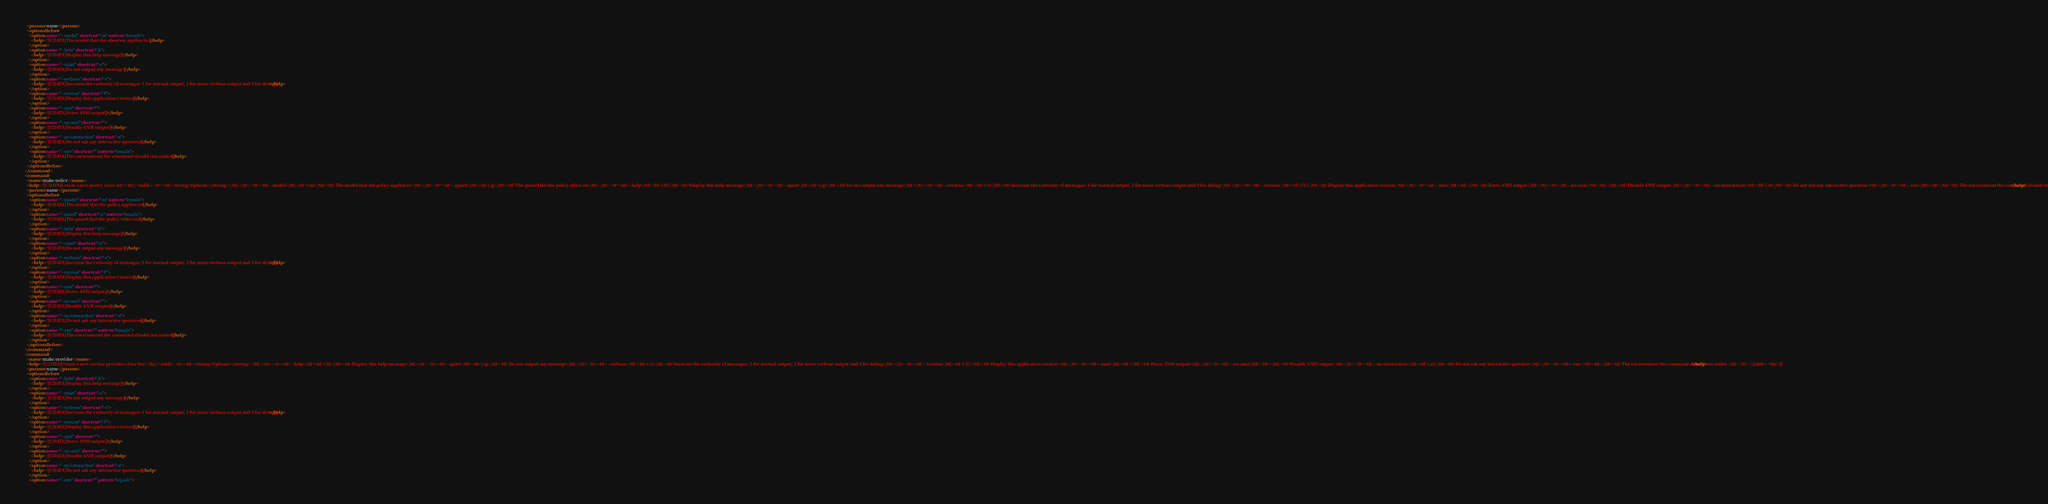Convert code to text. <code><loc_0><loc_0><loc_500><loc_500><_XML_>    <params>name</params>
    <optionsBefore>
      <option name="--model" shortcut="-m" pattern="equals">
        <help><![CDATA[The model that the observer applies to.]]></help>
      </option>
      <option name="--help" shortcut="-h">
        <help><![CDATA[Display this help message]]></help>
      </option>
      <option name="--quiet" shortcut="-q">
        <help><![CDATA[Do not output any message]]></help>
      </option>
      <option name="--verbose" shortcut="-v">
        <help><![CDATA[Increase the verbosity of messages: 1 for normal output, 2 for more verbose output and 3 for debug]]></help>
      </option>
      <option name="--version" shortcut="-V">
        <help><![CDATA[Display this application version]]></help>
      </option>
      <option name="--ansi" shortcut="">
        <help><![CDATA[Force ANSI output]]></help>
      </option>
      <option name="--no-ansi" shortcut="">
        <help><![CDATA[Disable ANSI output]]></help>
      </option>
      <option name="--no-interaction" shortcut="-n">
        <help><![CDATA[Do not ask any interactive question]]></help>
      </option>
      <option name="--env" shortcut="" pattern="equals">
        <help><![CDATA[The environment the command should run under]]></help>
      </option>
    </optionsBefore>
  </command>
  <command>
    <name>make:policy</name>
    <help><![CDATA[Create a new policy class<br/><br/><table> <tr><td><strong>Options:</strong></td></tr> <tr><td>--model</td><td>(-m)</td><td>The model that the policy applies to</td></tr> <tr><td>--guard</td><td>(-g)</td><td>The guard that the policy relies on</td></tr> <tr><td>--help</td><td>(-h)</td><td>Display this help message</td></tr> <tr><td>--quiet</td><td>(-q)</td><td>Do not output any message</td></tr> <tr><td>--verbose</td><td>(-v)</td><td>Increase the verbosity of messages: 1 for normal output, 2 for more verbose output and 3 for debug</td></tr> <tr><td>--version</td><td>(-V)</td><td>Display this application version</td></tr> <tr><td>--ansi</td><td></td><td>Force ANSI output</td></tr> <tr><td>--no-ansi</td><td></td><td>Disable ANSI output</td></tr> <tr><td>--no-interaction</td><td>(-n)</td><td>Do not ask any interactive question</td></tr> <tr><td>--env</td><td></td><td>The environment the command should run under</td></tr> </table> <br/>]]></help>
    <params>name</params>
    <optionsBefore>
      <option name="--model" shortcut="-m" pattern="equals">
        <help><![CDATA[The model that the policy applies to]]></help>
      </option>
      <option name="--guard" shortcut="-g" pattern="equals">
        <help><![CDATA[The guard that the policy relies on]]></help>
      </option>
      <option name="--help" shortcut="-h">
        <help><![CDATA[Display this help message]]></help>
      </option>
      <option name="--quiet" shortcut="-q">
        <help><![CDATA[Do not output any message]]></help>
      </option>
      <option name="--verbose" shortcut="-v">
        <help><![CDATA[Increase the verbosity of messages: 1 for normal output, 2 for more verbose output and 3 for debug]]></help>
      </option>
      <option name="--version" shortcut="-V">
        <help><![CDATA[Display this application version]]></help>
      </option>
      <option name="--ansi" shortcut="">
        <help><![CDATA[Force ANSI output]]></help>
      </option>
      <option name="--no-ansi" shortcut="">
        <help><![CDATA[Disable ANSI output]]></help>
      </option>
      <option name="--no-interaction" shortcut="-n">
        <help><![CDATA[Do not ask any interactive question]]></help>
      </option>
      <option name="--env" shortcut="" pattern="equals">
        <help><![CDATA[The environment the command should run under]]></help>
      </option>
    </optionsBefore>
  </command>
  <command>
    <name>make:provider</name>
    <help><![CDATA[Create a new service provider class<br/><br/><table> <tr><td><strong>Options:</strong></td></tr> <tr><td>--help</td><td>(-h)</td><td>Display this help message</td></tr> <tr><td>--quiet</td><td>(-q)</td><td>Do not output any message</td></tr> <tr><td>--verbose</td><td>(-v)</td><td>Increase the verbosity of messages: 1 for normal output, 2 for more verbose output and 3 for debug</td></tr> <tr><td>--version</td><td>(-V)</td><td>Display this application version</td></tr> <tr><td>--ansi</td><td></td><td>Force ANSI output</td></tr> <tr><td>--no-ansi</td><td></td><td>Disable ANSI output</td></tr> <tr><td>--no-interaction</td><td>(-n)</td><td>Do not ask any interactive question</td></tr> <tr><td>--env</td><td></td><td>The environment the command should run under</td></tr> </table> <br/>]]></help>
    <params>name</params>
    <optionsBefore>
      <option name="--help" shortcut="-h">
        <help><![CDATA[Display this help message]]></help>
      </option>
      <option name="--quiet" shortcut="-q">
        <help><![CDATA[Do not output any message]]></help>
      </option>
      <option name="--verbose" shortcut="-v">
        <help><![CDATA[Increase the verbosity of messages: 1 for normal output, 2 for more verbose output and 3 for debug]]></help>
      </option>
      <option name="--version" shortcut="-V">
        <help><![CDATA[Display this application version]]></help>
      </option>
      <option name="--ansi" shortcut="">
        <help><![CDATA[Force ANSI output]]></help>
      </option>
      <option name="--no-ansi" shortcut="">
        <help><![CDATA[Disable ANSI output]]></help>
      </option>
      <option name="--no-interaction" shortcut="-n">
        <help><![CDATA[Do not ask any interactive question]]></help>
      </option>
      <option name="--env" shortcut="" pattern="equals"></code> 